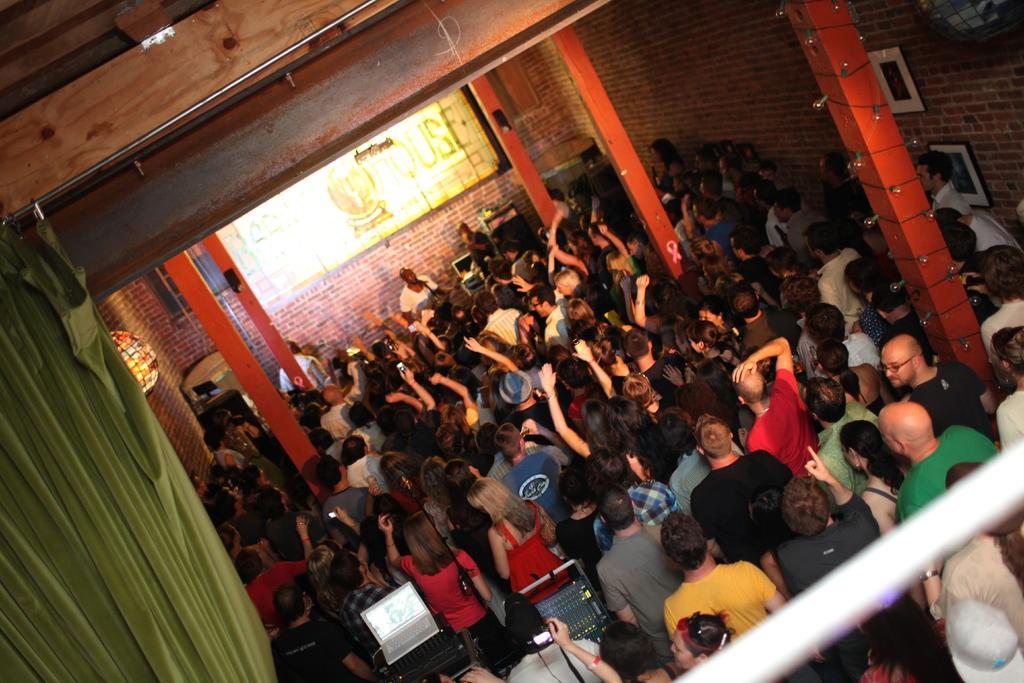Can you describe this image briefly? In this image there is a group of people standing in a hall, in that hall there are pillars, curtains, walls. 